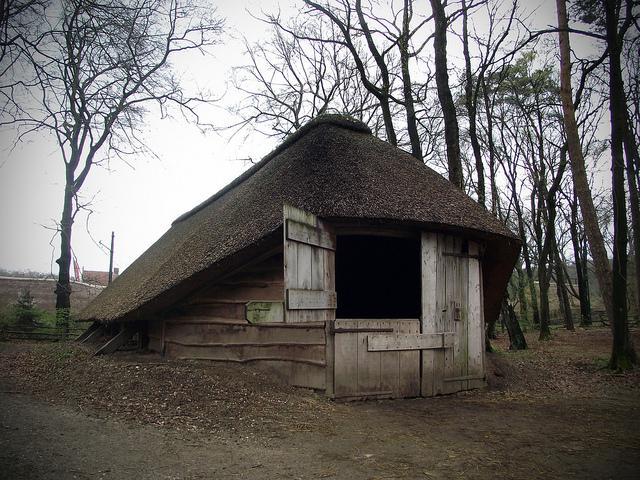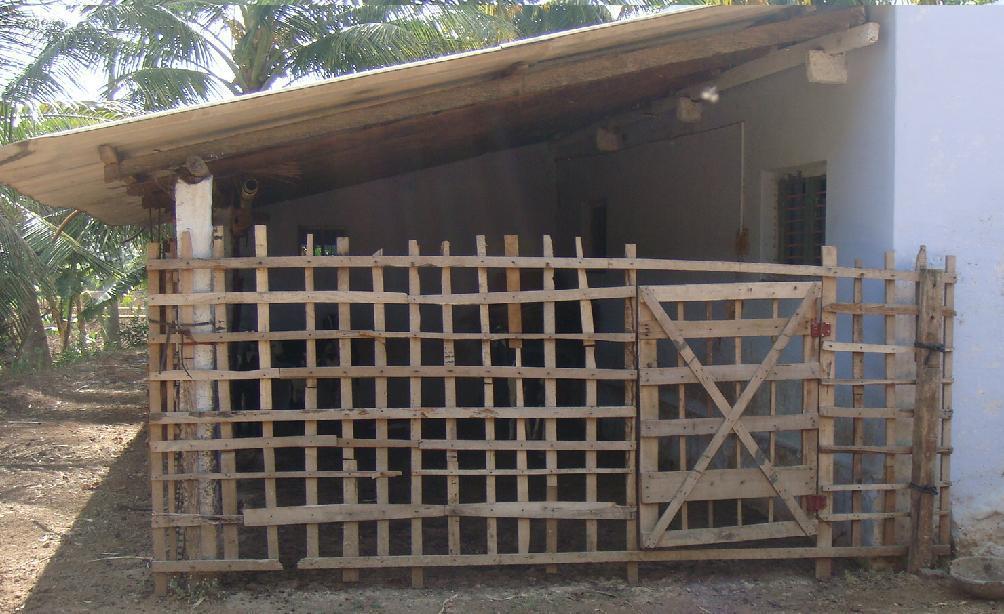The first image is the image on the left, the second image is the image on the right. For the images displayed, is the sentence "One house is shaped like a triangle." factually correct? Answer yes or no. No. The first image is the image on the left, the second image is the image on the right. Assess this claim about the two images: "In at least one image there is a building with a black hay roof.". Correct or not? Answer yes or no. Yes. 